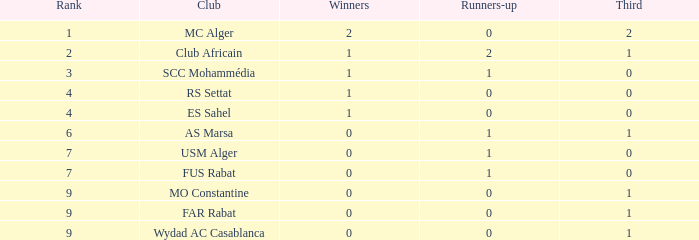Can you parse all the data within this table? {'header': ['Rank', 'Club', 'Winners', 'Runners-up', 'Third'], 'rows': [['1', 'MC Alger', '2', '0', '2'], ['2', 'Club Africain', '1', '2', '1'], ['3', 'SCC Mohammédia', '1', '1', '0'], ['4', 'RS Settat', '1', '0', '0'], ['4', 'ES Sahel', '1', '0', '0'], ['6', 'AS Marsa', '0', '1', '1'], ['7', 'USM Alger', '0', '1', '0'], ['7', 'FUS Rabat', '0', '1', '0'], ['9', 'MO Constantine', '0', '0', '1'], ['9', 'FAR Rabat', '0', '0', '1'], ['9', 'Wydad AC Casablanca', '0', '0', '1']]} How many conquerors contain a third of 1, and second-place contestants below 0? 0.0. 